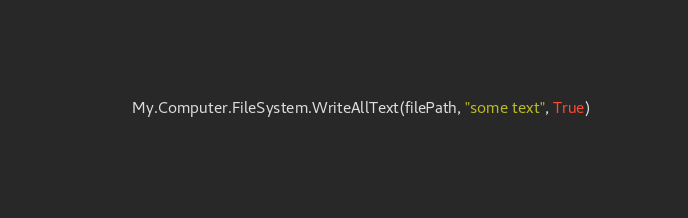<code> <loc_0><loc_0><loc_500><loc_500><_VisualBasic_>        My.Computer.FileSystem.WriteAllText(filePath, "some text", True)</code> 